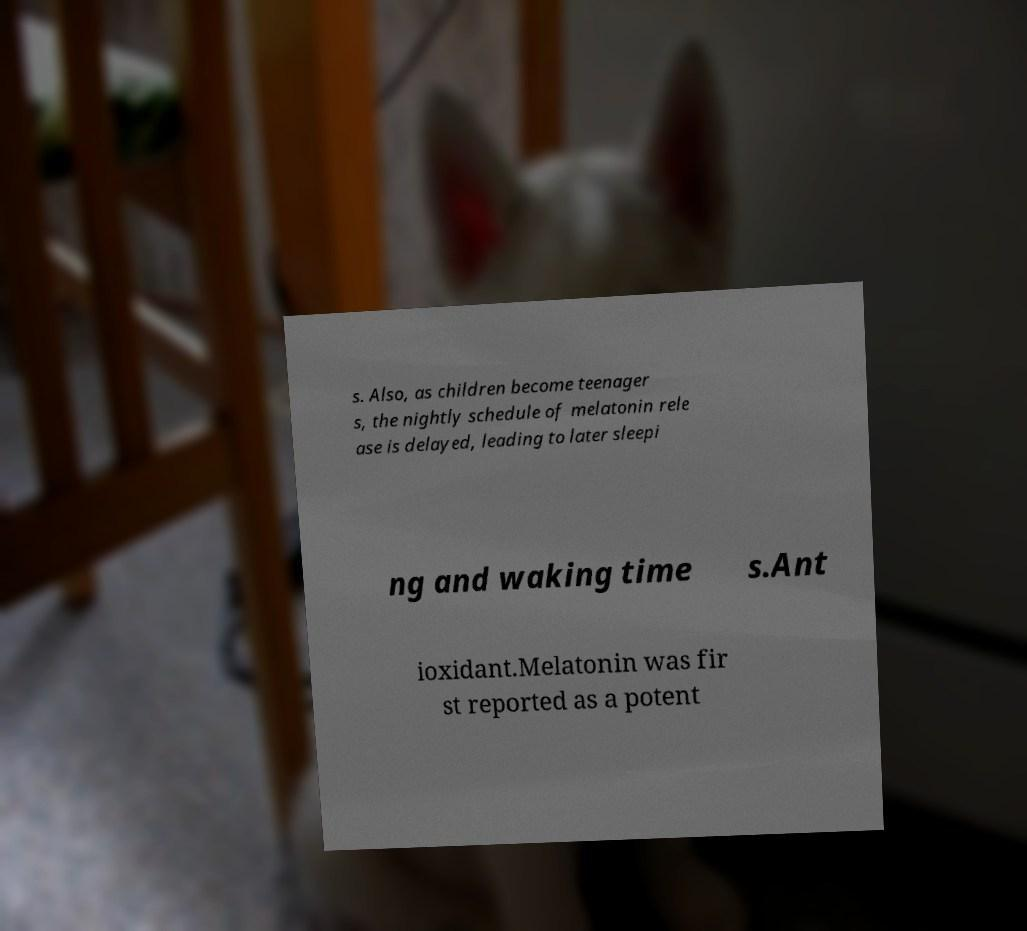Can you read and provide the text displayed in the image?This photo seems to have some interesting text. Can you extract and type it out for me? s. Also, as children become teenager s, the nightly schedule of melatonin rele ase is delayed, leading to later sleepi ng and waking time s.Ant ioxidant.Melatonin was fir st reported as a potent 